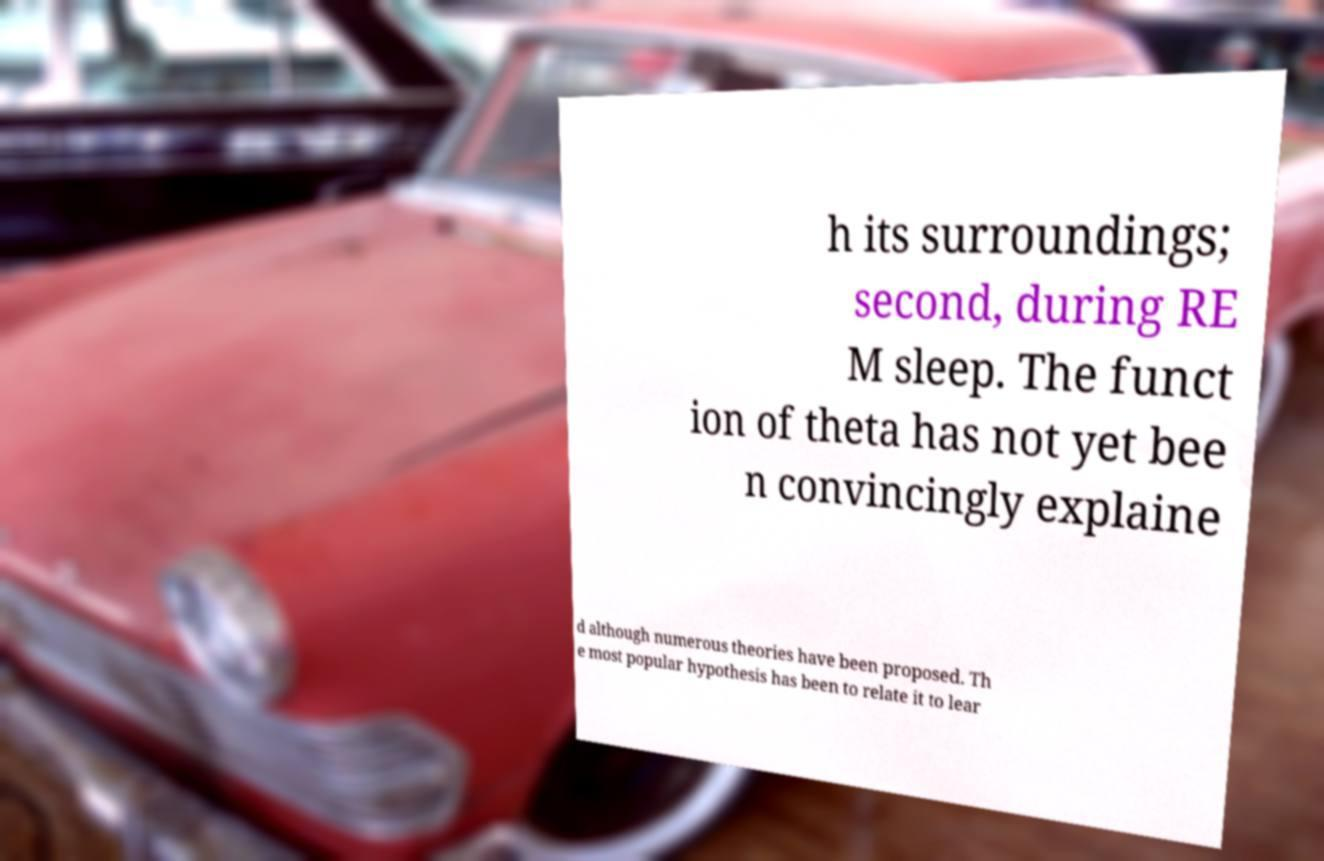There's text embedded in this image that I need extracted. Can you transcribe it verbatim? h its surroundings; second, during RE M sleep. The funct ion of theta has not yet bee n convincingly explaine d although numerous theories have been proposed. Th e most popular hypothesis has been to relate it to lear 